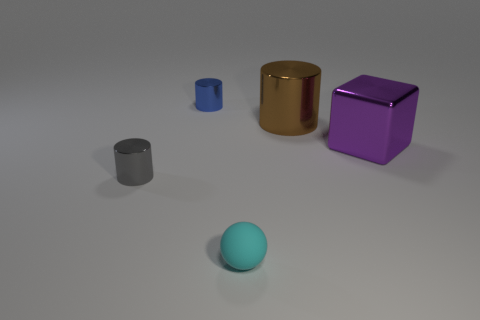Subtract all small shiny cylinders. How many cylinders are left? 1 Add 4 small red metal cylinders. How many objects exist? 9 Subtract 0 yellow blocks. How many objects are left? 5 Subtract all cylinders. How many objects are left? 2 Subtract all red cylinders. Subtract all cyan blocks. How many cylinders are left? 3 Subtract all gray cylinders. How many blue cubes are left? 0 Subtract all tiny gray matte balls. Subtract all cyan balls. How many objects are left? 4 Add 2 shiny cylinders. How many shiny cylinders are left? 5 Add 1 blue metallic objects. How many blue metallic objects exist? 2 